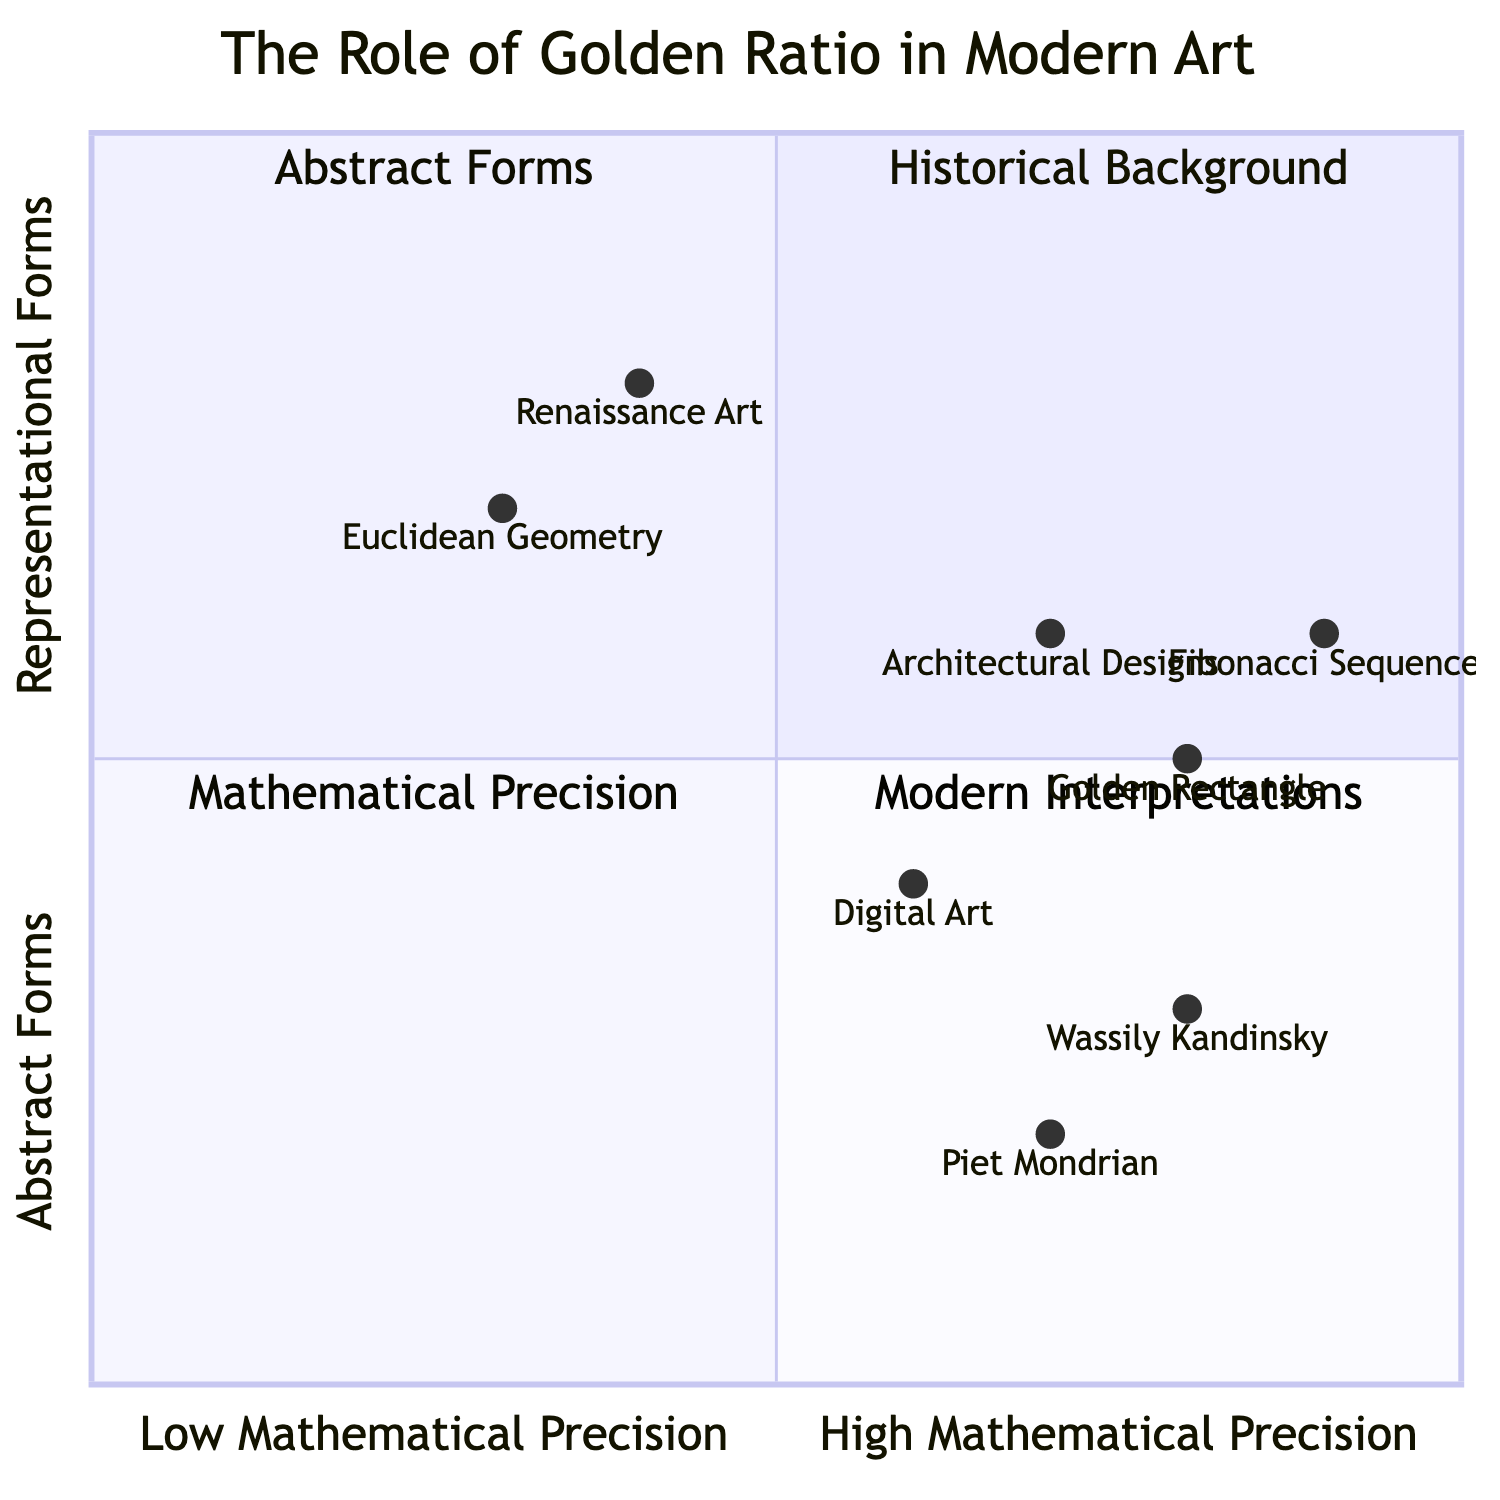What does the top left quadrant represent? The top left quadrant is labeled "Historical Background", which includes elements that discuss the origins and significance of the golden ratio in art and mathematics.
Answer: Historical Background Which artist's work is situated in the top right quadrant? In the top right quadrant labeled "Abstract Forms", the element "Piet Mondrian" is situated there, known for his use of grids and proportions.
Answer: Piet Mondrian How many elements are in the bottom left quadrant? The bottom left quadrant, titled "Mathematical Precision", contains two elements: "Fibonacci Sequence" and "Golden Rectangle". Thus, the number of elements is two.
Answer: 2 Which element has the highest mathematical precision? The element "Fibonacci Sequence" is the closest to the mathematical precision end on the x-axis with coordinates [0.9, 0.6].
Answer: Fibonacci Sequence What is the trend observed in the relationship between the "Digital Art" and "Architectural Designs"? Both elements are located in the bottom right quadrant, "Modern Interpretations", and both favor high levels of mathematical precision while embodying abstract forms, with "Architectural Designs" being slightly higher in mathematical precision than "Digital Art".
Answer: Similar trend Which quadrant features elements from both art history and modern art techniques? The quadrants to focus on for both elements are "Historical Background" in the top left and "Modern Interpretations" in the bottom right. However, no single quadrant contains elements from both categories.
Answer: None What is the x-axis scale range for the elements in the diagram? The x-axis range runs from Low Mathematical Precision to High Mathematical Precision, which is a qualitative scale rather than a numerical range. The values for elements illustrate positions along this axis from 0 to 1.
Answer: Low to High How does Wassily Kandinsky’s position reflect his approach to abstraction? Wassily Kandinsky is situated in the top right quadrant with coordinates [0.8, 0.3], indicating a high level of mathematical precision while remaining centered in abstract forms, embodying his tendency to blend math and art.
Answer: High Precision in Abstracts 